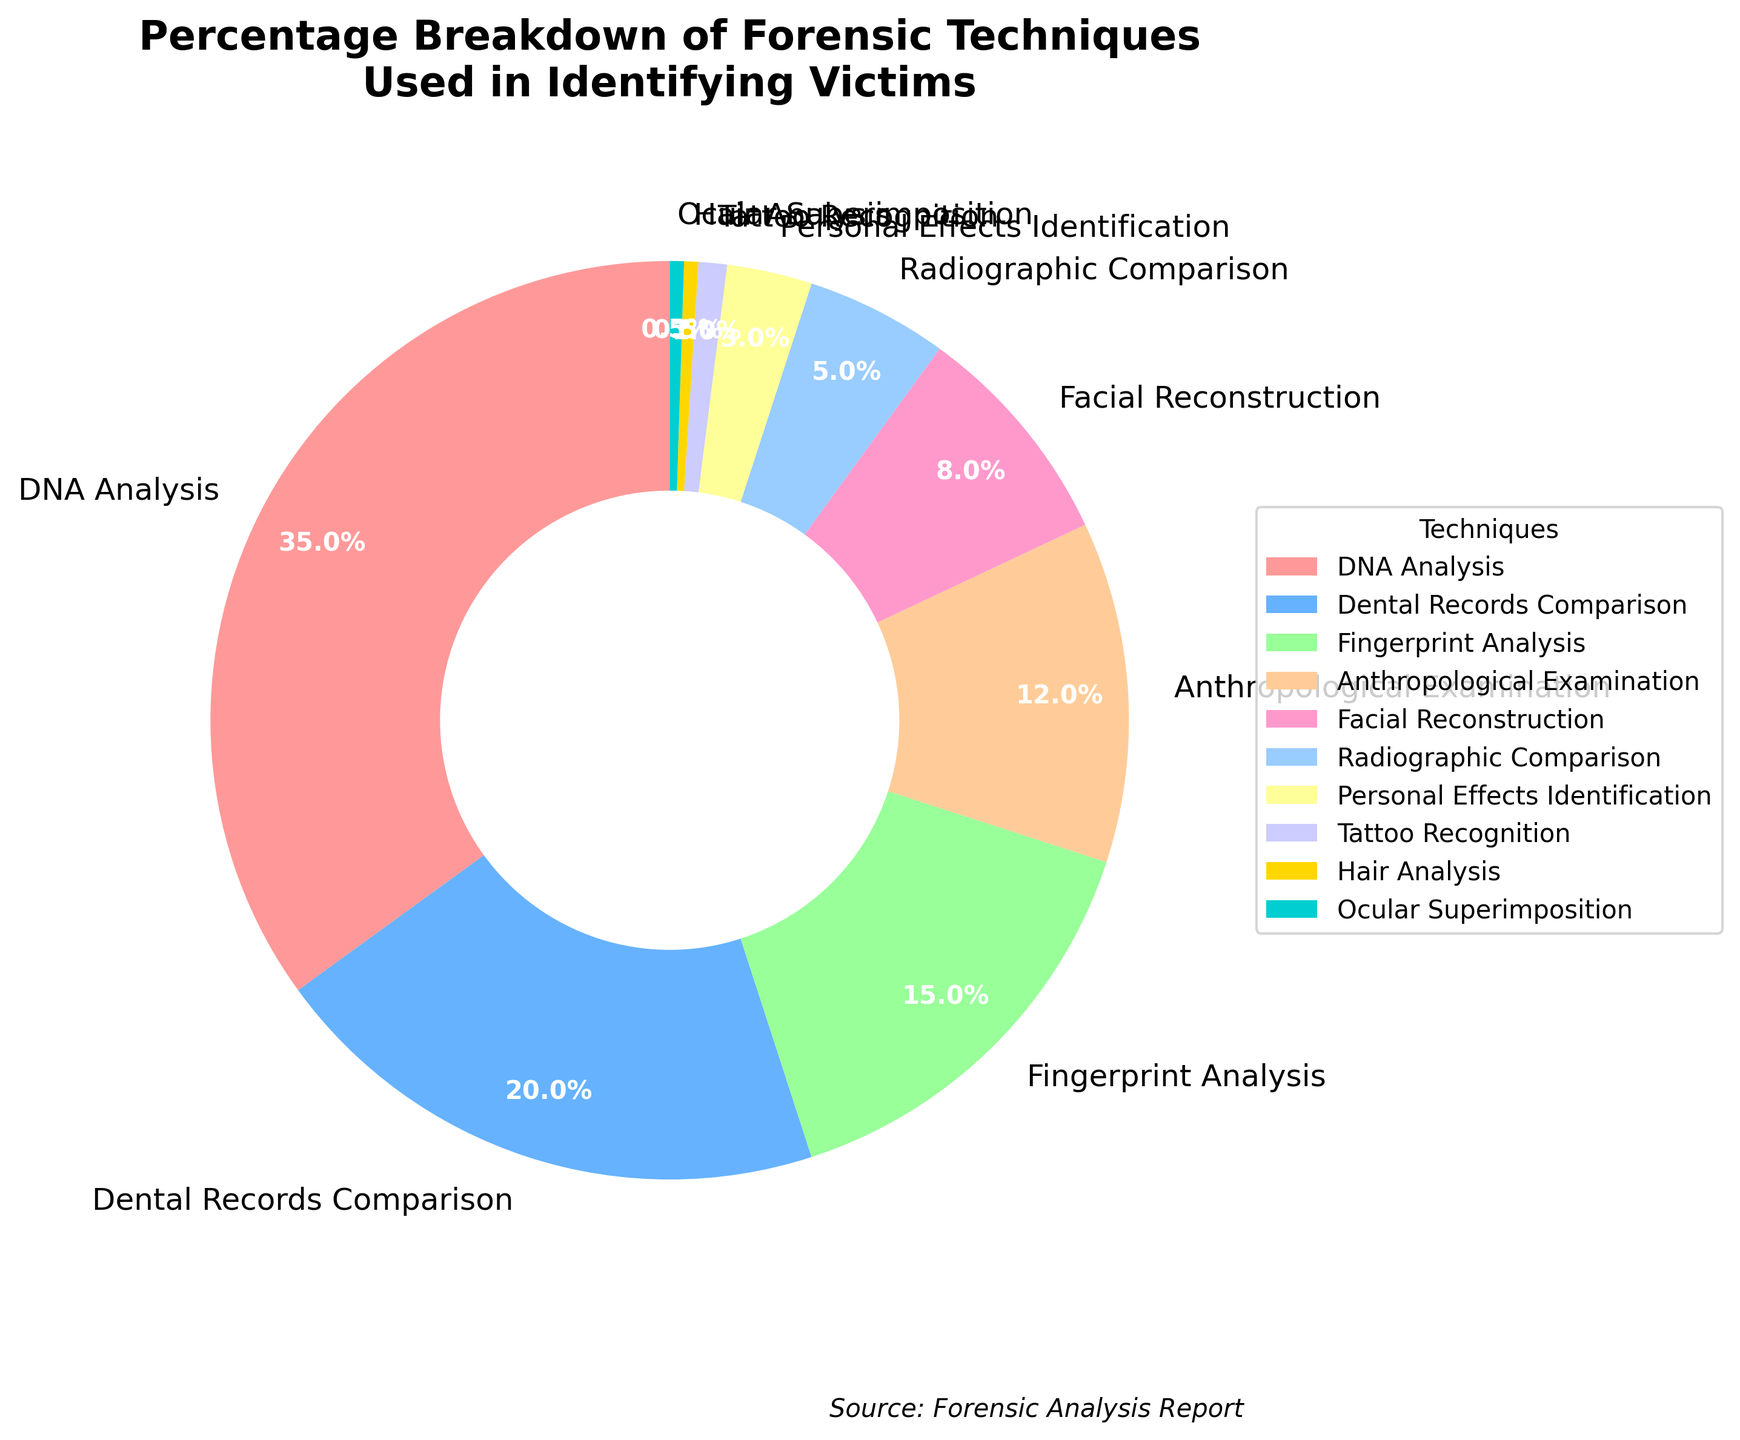What is the most commonly used forensic technique in identifying victims, according to the pie chart? The largest segment of the pie chart represents DNA Analysis. By comparing the segment sizes and the labels, it's clear that DNA Analysis is the most commonly used technique.
Answer: DNA Analysis What proportion of forensic techniques involve biometric identification methods (DNA Analysis, Fingerprint Analysis, and Dental Records Comparison)? To find the proportion, add the percentages of DNA Analysis (35%), Fingerprint Analysis (15%), and Dental Records Comparison (20%). This gives 35% + 15% + 20% = 70%.
Answer: 70% How does the usage percentage of Facial Reconstruction compare to Radiographic Comparison? According to the pie chart, Facial Reconstruction accounts for 8% while Radiographic Comparison accounts for 5%. By comparing these percentages, it’s clear that Facial Reconstruction is used more often than Radiographic Comparison.
Answer: Facial Reconstruction is used more often Which forensic techniques have the least percentage of usage and what are their combined percentage? The pie chart shows that Hair Analysis and Ocular Superimposition both have the smallest segments, each with 0.5%. Adding them together gives 0.5% + 0.5% = 1%.
Answer: Hair Analysis and Ocular Superimposition, combined percentage is 1% What is the sum of percentages for techniques that are used less than 10% of the time each? The techniques used less than 10% are: Facial Reconstruction (8%), Radiographic Comparison (5%), Personal Effects Identification (3%), Tattoo Recognition (1%), Hair Analysis (0.5%), and Ocular Superimposition (0.5%). Adding these gives 8% + 5% + 3% + 1% + 0.5% + 0.5% = 18%.
Answer: 18% By what percentage does DNA Analysis exceed Dental Records Comparison in usage? DNA Analysis has a usage percentage of 35%, while Dental Records Comparison has 20%. The difference is 35% - 20% = 15%.
Answer: 15% Which forensic techniques are represented by colors associated with shades of blue, and what are their combined percentages? By examining the pie chart's color legend, the techniques represented by blue shades are Dental Records Comparison (20%) and Radiographic Comparison (5%). Adding these percentages gives 20% + 5% = 25%.
Answer: Dental Records Comparison and Radiographic Comparison, 25% How many forensic techniques are used less than 5% of the time each, and what are they? Referring to the pie chart, the techniques used less than 5% of the time are Radiographic Comparison (5%), Personal Effects Identification (3%), Tattoo Recognition (1%), Hair Analysis (0.5%), and Ocular Superimposition (0.5%). Counting these techniques gives a total of 5.
Answer: 5, Radiographic Comparison, Personal Effects Identification, Tattoo Recognition, Hair Analysis, Ocular Superimposition 